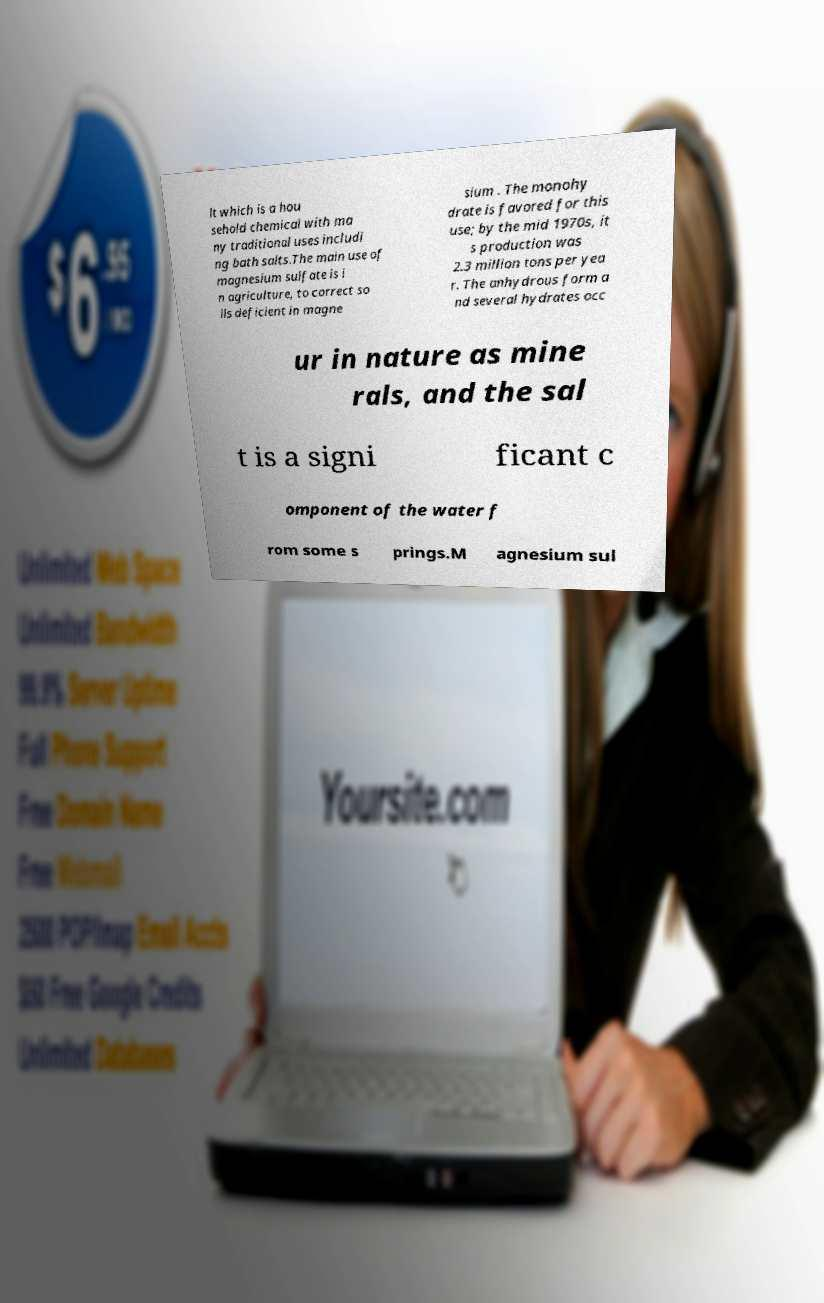Please read and relay the text visible in this image. What does it say? lt which is a hou sehold chemical with ma ny traditional uses includi ng bath salts.The main use of magnesium sulfate is i n agriculture, to correct so ils deficient in magne sium . The monohy drate is favored for this use; by the mid 1970s, it s production was 2.3 million tons per yea r. The anhydrous form a nd several hydrates occ ur in nature as mine rals, and the sal t is a signi ficant c omponent of the water f rom some s prings.M agnesium sul 